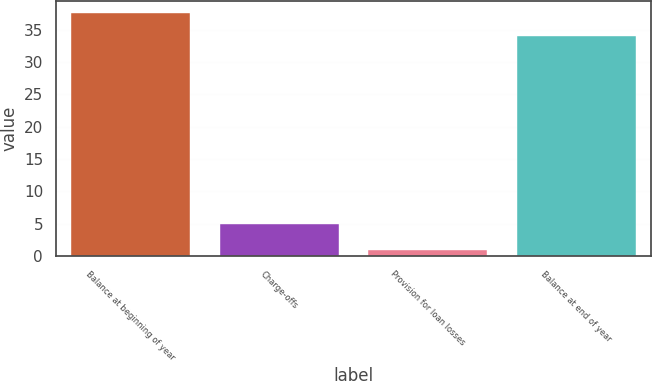Convert chart to OTSL. <chart><loc_0><loc_0><loc_500><loc_500><bar_chart><fcel>Balance at beginning of year<fcel>Charge-offs<fcel>Provision for loan losses<fcel>Balance at end of year<nl><fcel>37.5<fcel>5<fcel>1<fcel>34<nl></chart> 